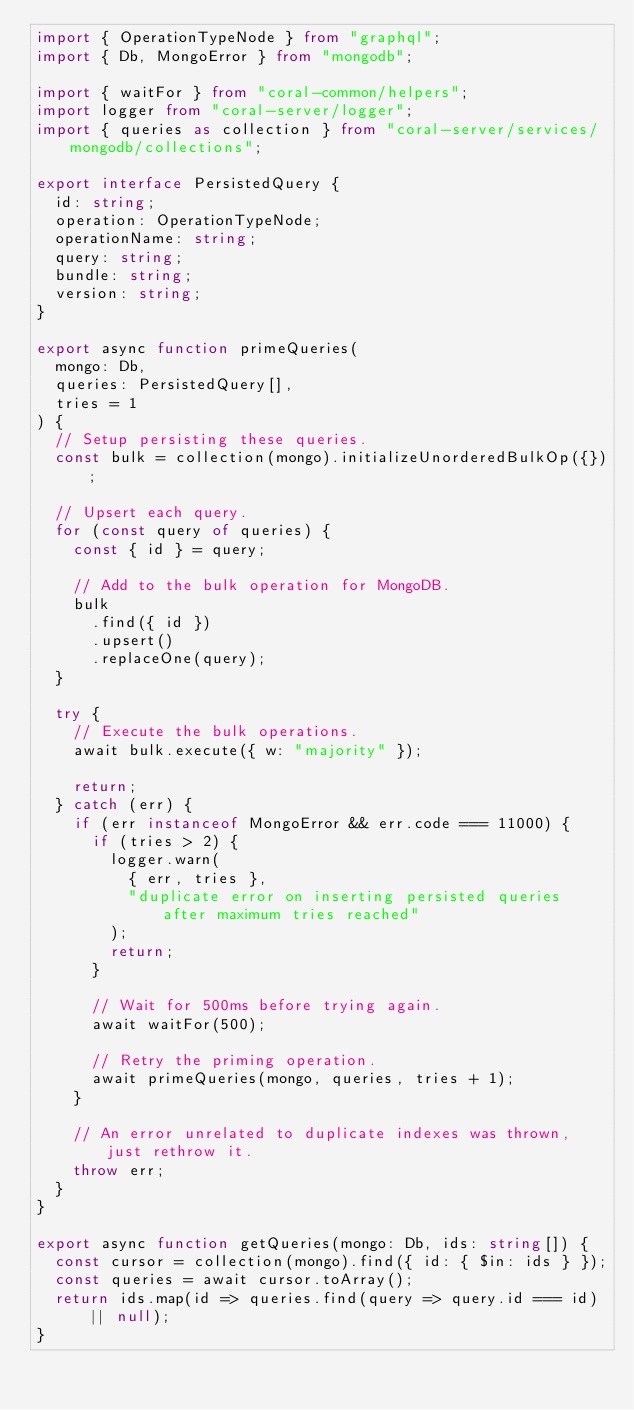<code> <loc_0><loc_0><loc_500><loc_500><_TypeScript_>import { OperationTypeNode } from "graphql";
import { Db, MongoError } from "mongodb";

import { waitFor } from "coral-common/helpers";
import logger from "coral-server/logger";
import { queries as collection } from "coral-server/services/mongodb/collections";

export interface PersistedQuery {
  id: string;
  operation: OperationTypeNode;
  operationName: string;
  query: string;
  bundle: string;
  version: string;
}

export async function primeQueries(
  mongo: Db,
  queries: PersistedQuery[],
  tries = 1
) {
  // Setup persisting these queries.
  const bulk = collection(mongo).initializeUnorderedBulkOp({});

  // Upsert each query.
  for (const query of queries) {
    const { id } = query;

    // Add to the bulk operation for MongoDB.
    bulk
      .find({ id })
      .upsert()
      .replaceOne(query);
  }

  try {
    // Execute the bulk operations.
    await bulk.execute({ w: "majority" });

    return;
  } catch (err) {
    if (err instanceof MongoError && err.code === 11000) {
      if (tries > 2) {
        logger.warn(
          { err, tries },
          "duplicate error on inserting persisted queries after maximum tries reached"
        );
        return;
      }

      // Wait for 500ms before trying again.
      await waitFor(500);

      // Retry the priming operation.
      await primeQueries(mongo, queries, tries + 1);
    }

    // An error unrelated to duplicate indexes was thrown, just rethrow it.
    throw err;
  }
}

export async function getQueries(mongo: Db, ids: string[]) {
  const cursor = collection(mongo).find({ id: { $in: ids } });
  const queries = await cursor.toArray();
  return ids.map(id => queries.find(query => query.id === id) || null);
}
</code> 